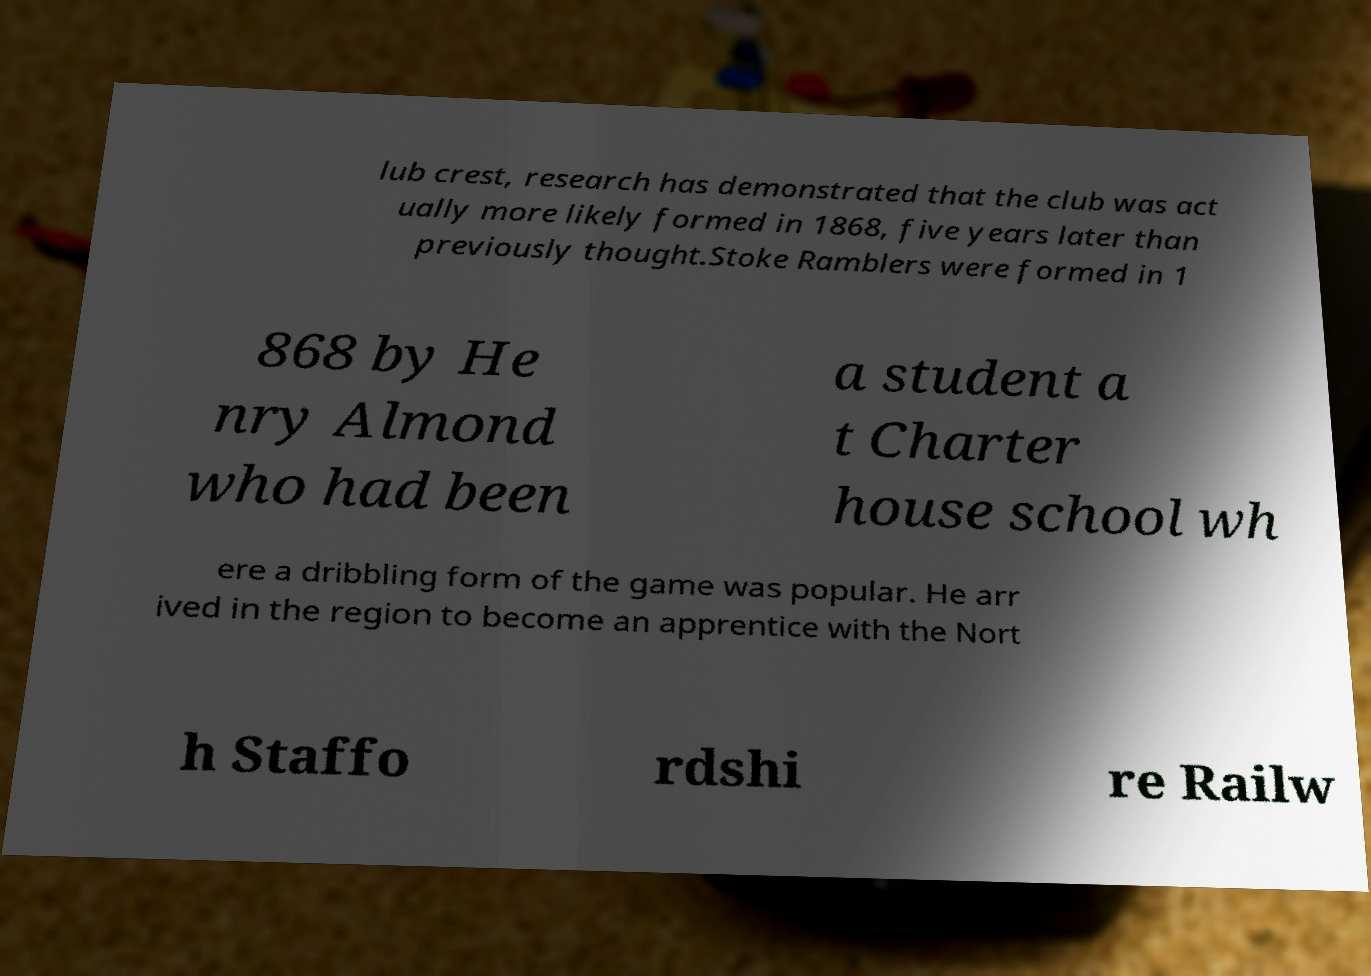What messages or text are displayed in this image? I need them in a readable, typed format. lub crest, research has demonstrated that the club was act ually more likely formed in 1868, five years later than previously thought.Stoke Ramblers were formed in 1 868 by He nry Almond who had been a student a t Charter house school wh ere a dribbling form of the game was popular. He arr ived in the region to become an apprentice with the Nort h Staffo rdshi re Railw 